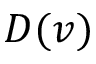Convert formula to latex. <formula><loc_0><loc_0><loc_500><loc_500>D ( v )</formula> 